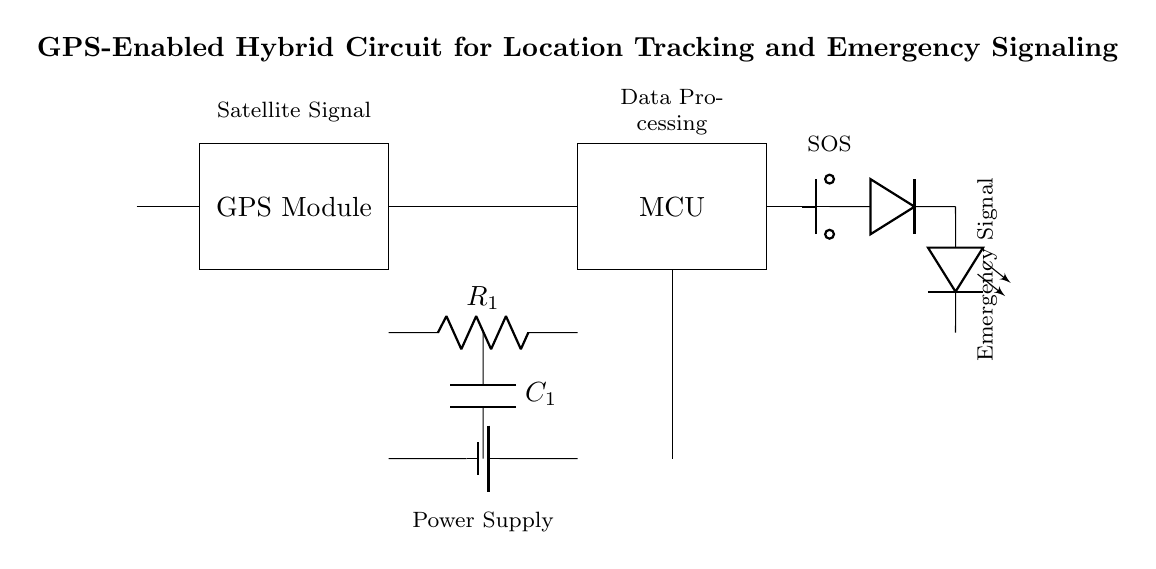What is the main function of the GPS module? The GPS module retrieves satellite signals for location tracking, which is indicated by its label in the circuit diagram.
Answer: location tracking What type of microcontroller is used in this circuit? The circuit does not specify a particular type of microcontroller; it is labeled simply as MCU, which stands for Microcontroller Unit.
Answer: MCU How many resistors are present in the circuit? There is one resistor labeled as R1 in the circuit diagram, indicating that it is the only resistor component present.
Answer: 1 What is the role of the antenna? The antenna receives signals from satellites, enabling the GPS module to function properly for location tracking.
Answer: signal reception What occurs when the emergency button is pressed? Pressing the emergency button triggers the emergency signaling circuit, which is represented by the connection to the LED and labeled "SOS."
Answer: SOS signal What are the two main types of components in this hybrid circuit? The hybrid circuit consists of analog components (like the resistor and capacitor) and digital components (like the microcontroller and LED).
Answer: analog and digital What is the purpose of the battery in this circuit? The battery provides the necessary power to all components, ensuring that the circuit operates continuously and effectively in both tracking and signaling functions.
Answer: power supply 